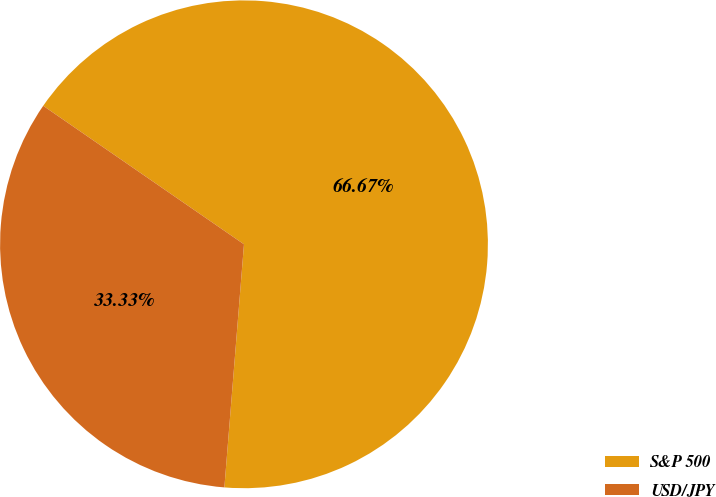Convert chart. <chart><loc_0><loc_0><loc_500><loc_500><pie_chart><fcel>S&P 500<fcel>USD/JPY<nl><fcel>66.67%<fcel>33.33%<nl></chart> 